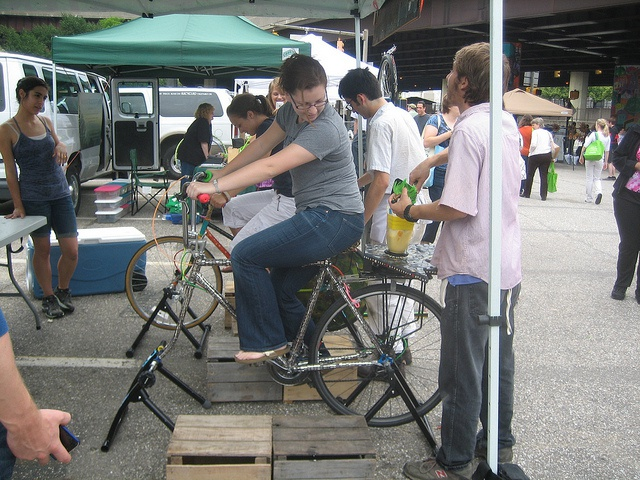Describe the objects in this image and their specific colors. I can see people in darkgreen, lavender, gray, black, and darkgray tones, people in darkgreen, black, gray, darkblue, and blue tones, bicycle in darkgreen, black, gray, darkgray, and lightgray tones, truck in darkgreen, black, gray, white, and darkgray tones, and people in darkgreen, black, gray, and maroon tones in this image. 